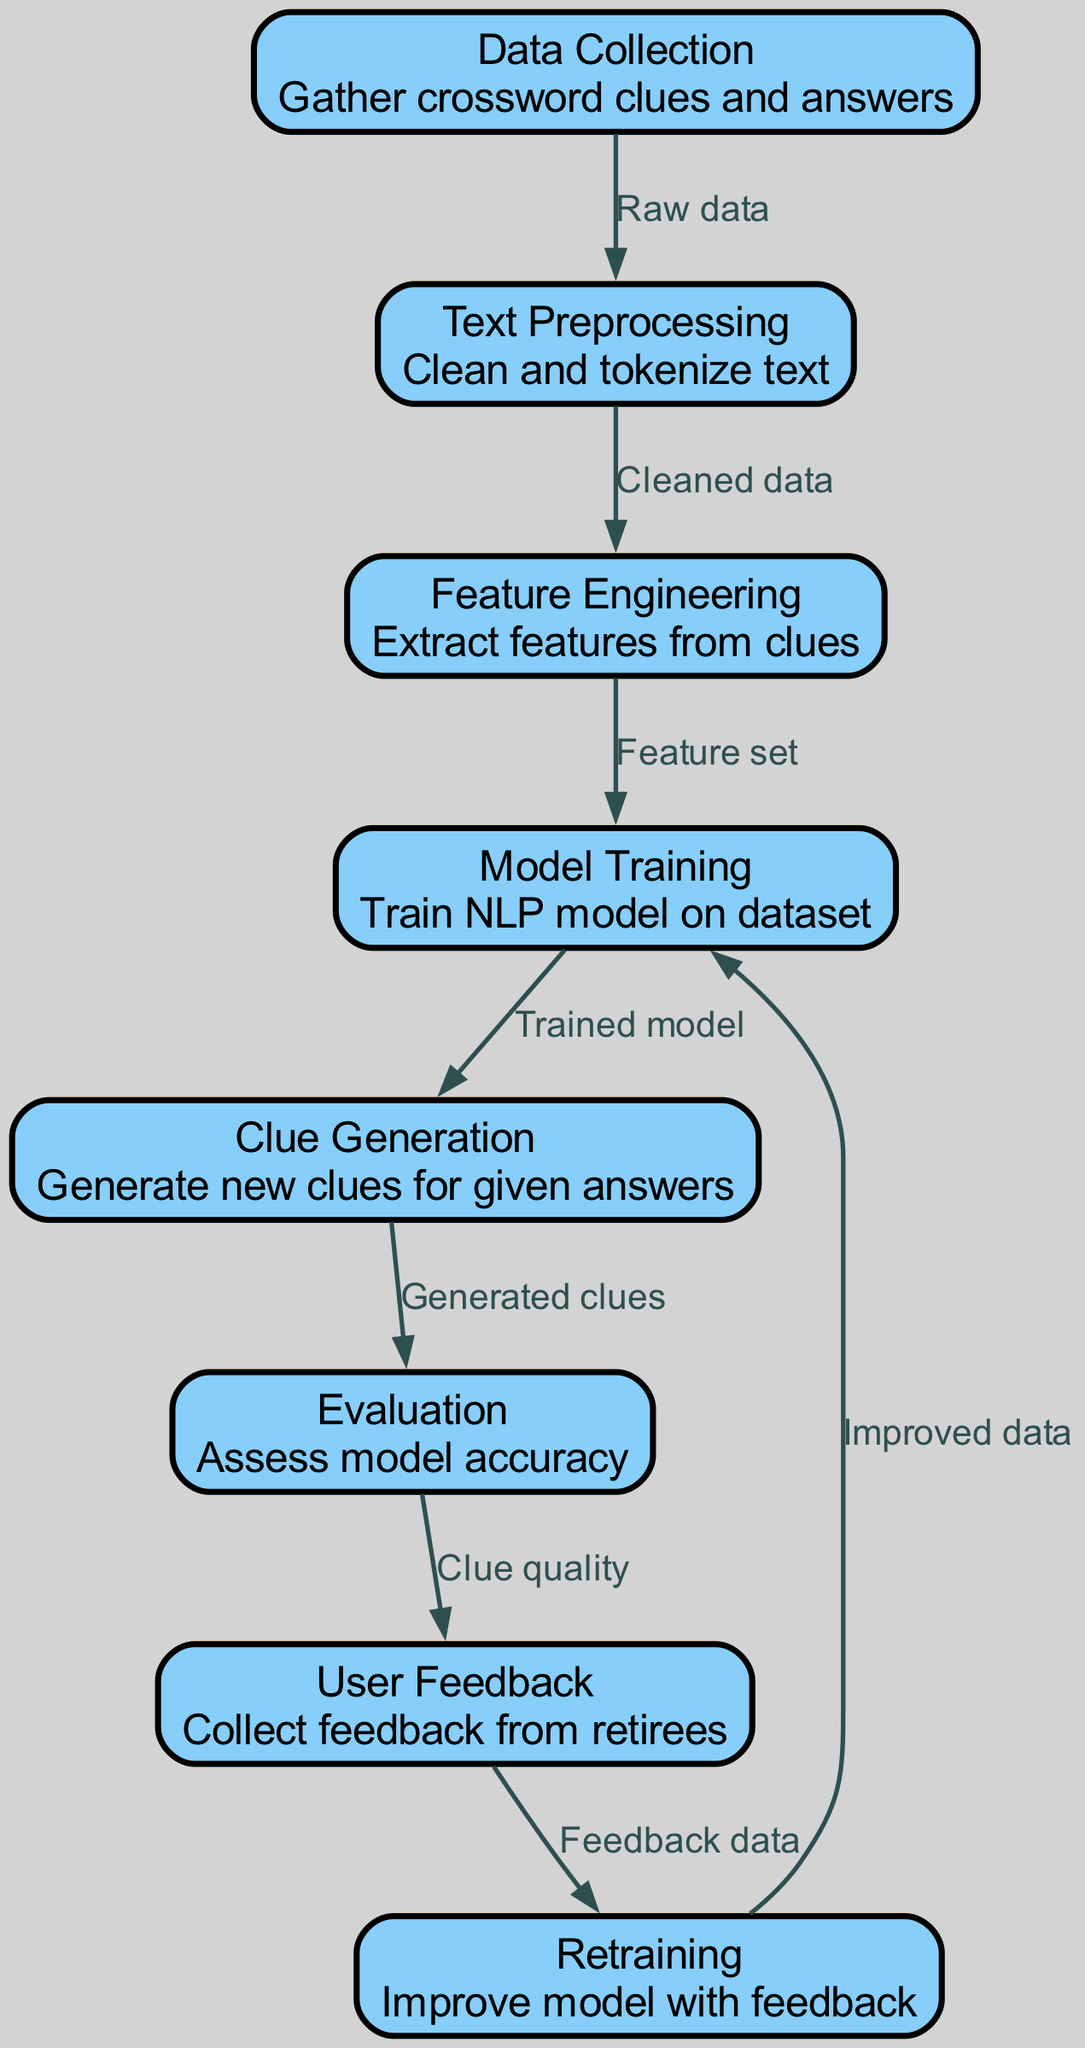What is the first step in the workflow? The first step is labeled "Data Collection," which involves gathering crossword clues and answers. This information is clearly marked in the diagram as the starting point of the workflow.
Answer: Data Collection How many nodes are in the diagram? The diagram contains a total of eight nodes, each representing distinct stages or components within the workflow. By counting each labeled box in the diagram, you can see that they total to eight.
Answer: Eight What is the relationship between "Model Training" and "Clue Generation"? "Model Training" sends its output, labeled "Trained model," directly to "Clue Generation." This indicates that the clues are generated based on the model that has been trained in the previous step.
Answer: Trained model Which node directly receives feedback? The node that directly receives feedback is labeled "User Feedback." It is the step in the workflow where feedback data from users is collected for further assessment of the generated clues.
Answer: User Feedback What is the last step in the process? The last step in the process is "Retraining," where the model is improved using the feedback collected from retirees. This indicates that the workflow ends with an effort to enhance the system based on user insights.
Answer: Retraining How does "Clue Generation" relate to "Evaluation"? "Clue Generation" produces output labeled "Generated clues," which is then evaluated in the "Evaluation" node. This shows a sequential relationship where generated clues are assessed for quality and accuracy after they are created.
Answer: Generated clues What does "Feature Engineering" use as input? "Feature Engineering" uses "Cleaned data" as input, which comes from the "Text Preprocessing" step. This indicates that the features extracted will be based on the preprocessed textual data.
Answer: Cleaned data Which node is immediately after "Evaluation"? The node immediately following "Evaluation" is "User Feedback." This indicates that after evaluating the model's performance, the system seeks input from users to enhance quality.
Answer: User Feedback 